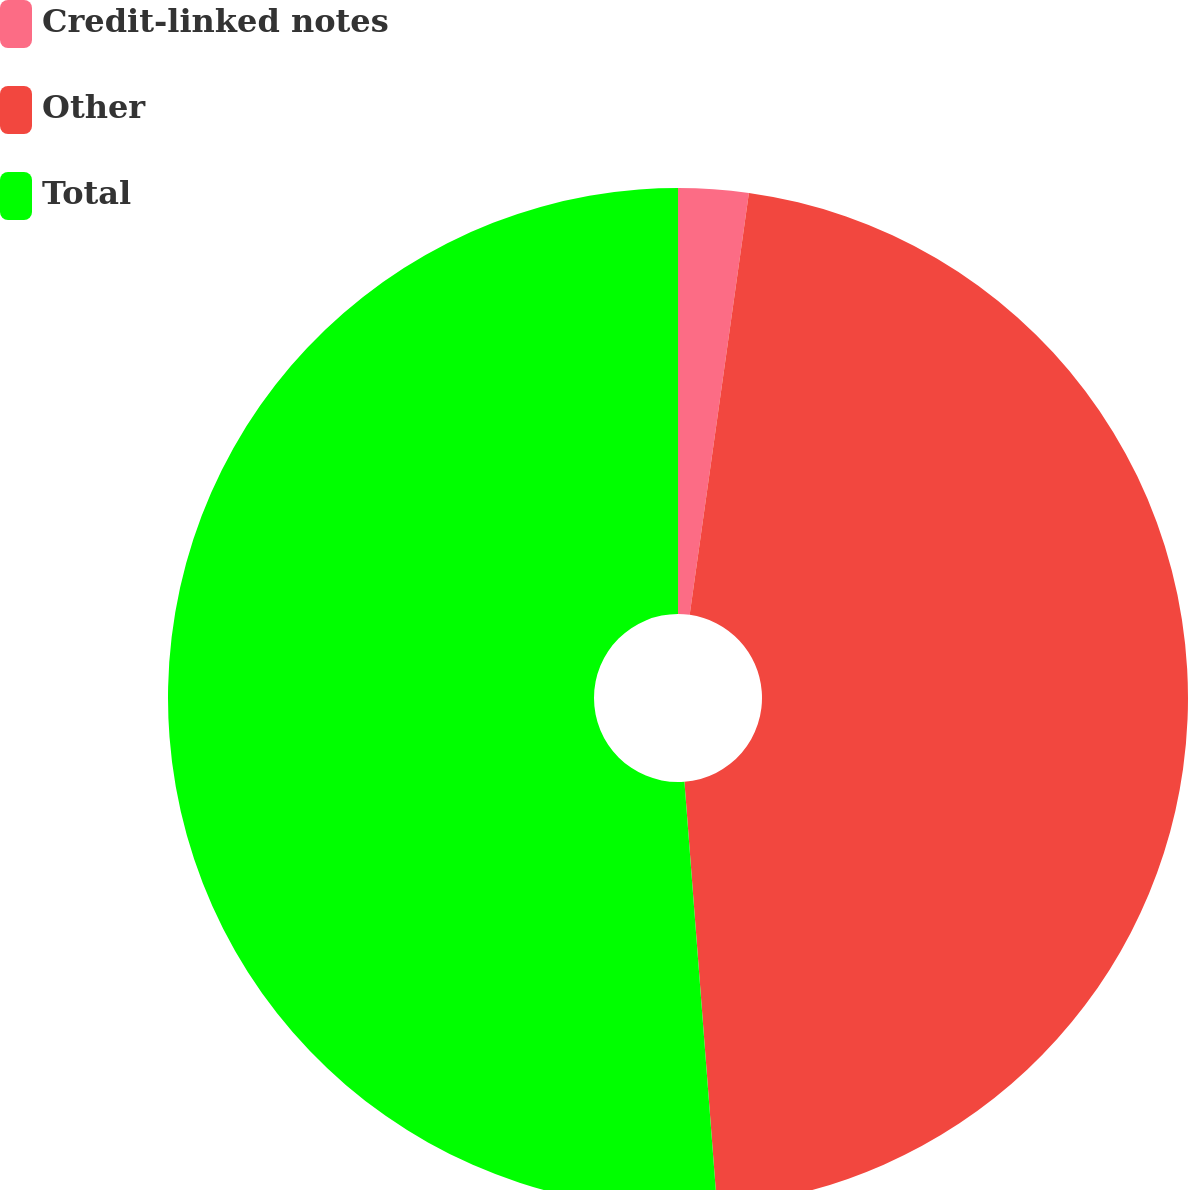Convert chart to OTSL. <chart><loc_0><loc_0><loc_500><loc_500><pie_chart><fcel>Credit-linked notes<fcel>Other<fcel>Total<nl><fcel>2.22%<fcel>46.56%<fcel>51.22%<nl></chart> 